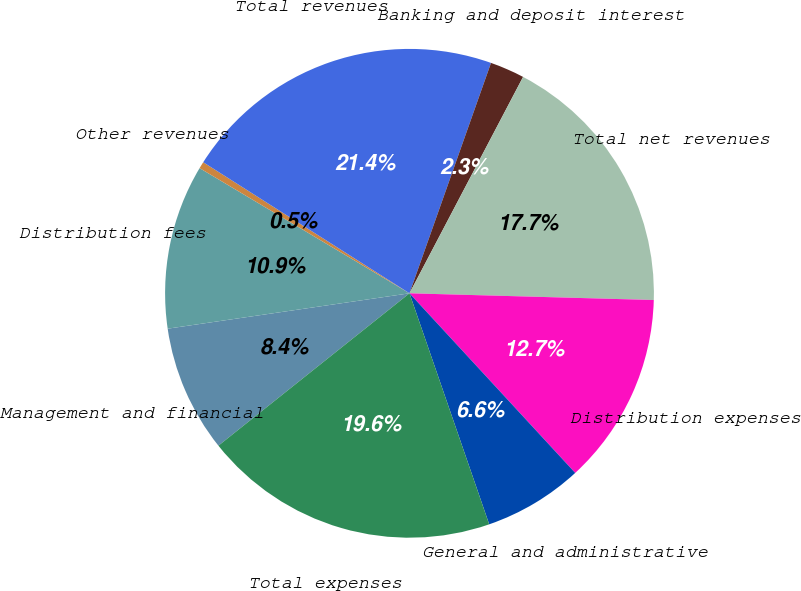<chart> <loc_0><loc_0><loc_500><loc_500><pie_chart><fcel>Management and financial<fcel>Distribution fees<fcel>Other revenues<fcel>Total revenues<fcel>Banking and deposit interest<fcel>Total net revenues<fcel>Distribution expenses<fcel>General and administrative<fcel>Total expenses<nl><fcel>8.4%<fcel>10.87%<fcel>0.45%<fcel>21.4%<fcel>2.28%<fcel>17.74%<fcel>12.7%<fcel>6.57%<fcel>19.57%<nl></chart> 